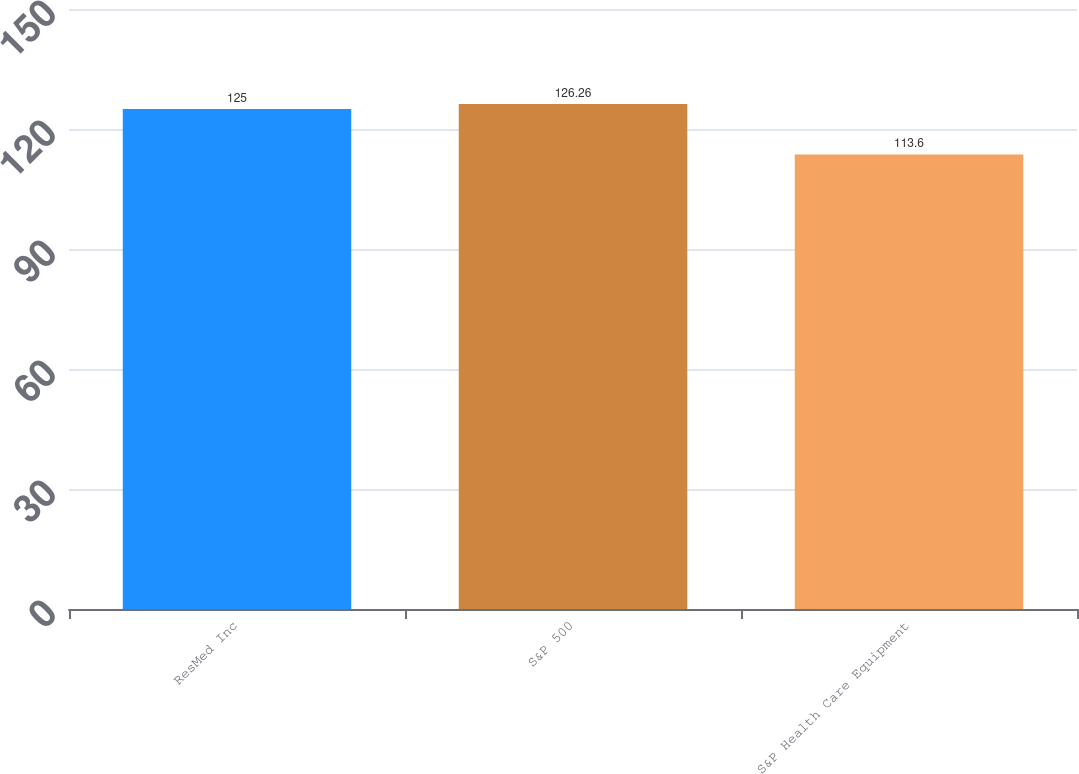Convert chart. <chart><loc_0><loc_0><loc_500><loc_500><bar_chart><fcel>ResMed Inc<fcel>S&P 500<fcel>S&P Health Care Equipment<nl><fcel>125<fcel>126.26<fcel>113.6<nl></chart> 